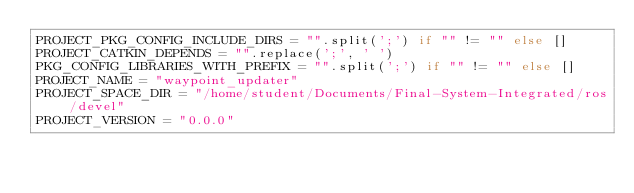Convert code to text. <code><loc_0><loc_0><loc_500><loc_500><_Python_>PROJECT_PKG_CONFIG_INCLUDE_DIRS = "".split(';') if "" != "" else []
PROJECT_CATKIN_DEPENDS = "".replace(';', ' ')
PKG_CONFIG_LIBRARIES_WITH_PREFIX = "".split(';') if "" != "" else []
PROJECT_NAME = "waypoint_updater"
PROJECT_SPACE_DIR = "/home/student/Documents/Final-System-Integrated/ros/devel"
PROJECT_VERSION = "0.0.0"
</code> 